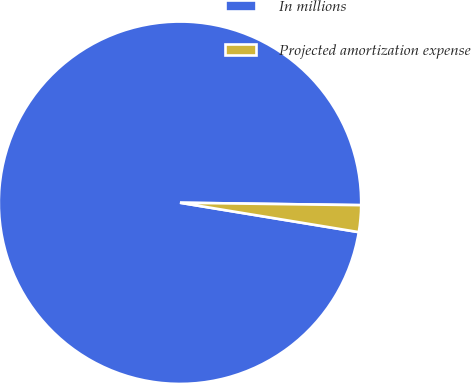Convert chart. <chart><loc_0><loc_0><loc_500><loc_500><pie_chart><fcel>In millions<fcel>Projected amortization expense<nl><fcel>97.62%<fcel>2.38%<nl></chart> 